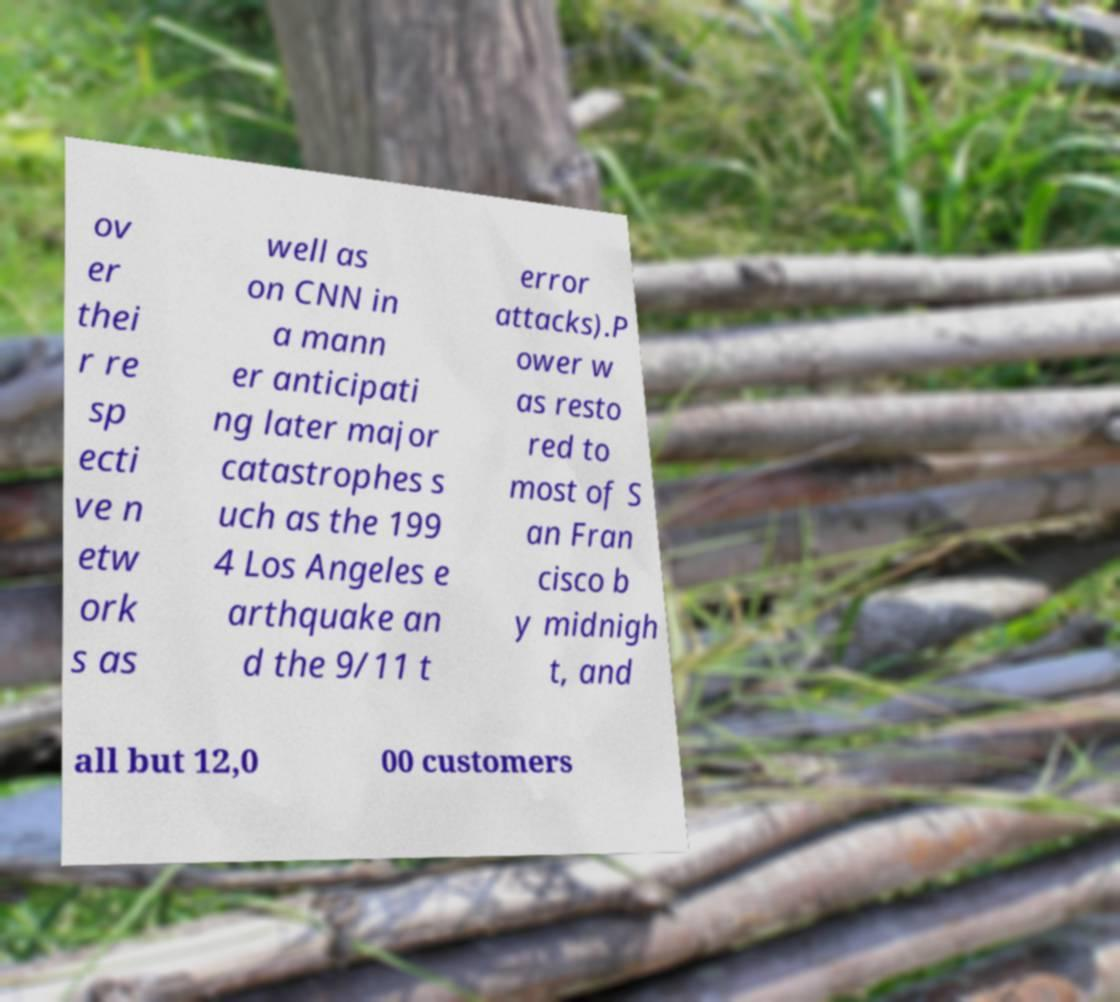Could you assist in decoding the text presented in this image and type it out clearly? ov er thei r re sp ecti ve n etw ork s as well as on CNN in a mann er anticipati ng later major catastrophes s uch as the 199 4 Los Angeles e arthquake an d the 9/11 t error attacks).P ower w as resto red to most of S an Fran cisco b y midnigh t, and all but 12,0 00 customers 